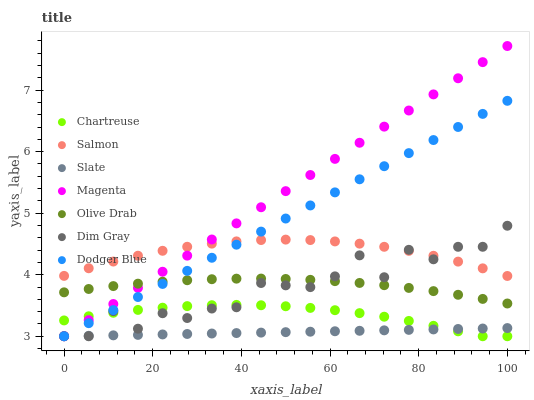Does Slate have the minimum area under the curve?
Answer yes or no. Yes. Does Magenta have the maximum area under the curve?
Answer yes or no. Yes. Does Salmon have the minimum area under the curve?
Answer yes or no. No. Does Salmon have the maximum area under the curve?
Answer yes or no. No. Is Slate the smoothest?
Answer yes or no. Yes. Is Dim Gray the roughest?
Answer yes or no. Yes. Is Salmon the smoothest?
Answer yes or no. No. Is Salmon the roughest?
Answer yes or no. No. Does Dim Gray have the lowest value?
Answer yes or no. Yes. Does Salmon have the lowest value?
Answer yes or no. No. Does Magenta have the highest value?
Answer yes or no. Yes. Does Salmon have the highest value?
Answer yes or no. No. Is Slate less than Salmon?
Answer yes or no. Yes. Is Salmon greater than Chartreuse?
Answer yes or no. Yes. Does Salmon intersect Magenta?
Answer yes or no. Yes. Is Salmon less than Magenta?
Answer yes or no. No. Is Salmon greater than Magenta?
Answer yes or no. No. Does Slate intersect Salmon?
Answer yes or no. No. 